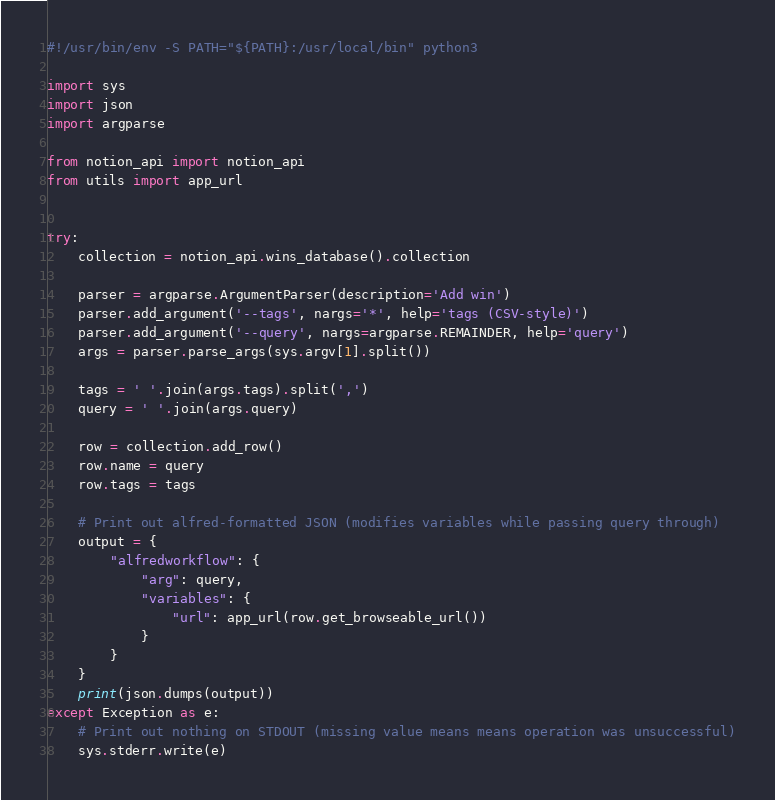Convert code to text. <code><loc_0><loc_0><loc_500><loc_500><_Python_>#!/usr/bin/env -S PATH="${PATH}:/usr/local/bin" python3

import sys
import json
import argparse

from notion_api import notion_api
from utils import app_url


try:
    collection = notion_api.wins_database().collection

    parser = argparse.ArgumentParser(description='Add win')
    parser.add_argument('--tags', nargs='*', help='tags (CSV-style)')
    parser.add_argument('--query', nargs=argparse.REMAINDER, help='query')
    args = parser.parse_args(sys.argv[1].split())

    tags = ' '.join(args.tags).split(',')
    query = ' '.join(args.query)

    row = collection.add_row()
    row.name = query
    row.tags = tags

    # Print out alfred-formatted JSON (modifies variables while passing query through)
    output = {
        "alfredworkflow": {
            "arg": query,
            "variables": {
                "url": app_url(row.get_browseable_url())
            }
        }
    }
    print(json.dumps(output))
except Exception as e:
    # Print out nothing on STDOUT (missing value means means operation was unsuccessful)
    sys.stderr.write(e)
</code> 